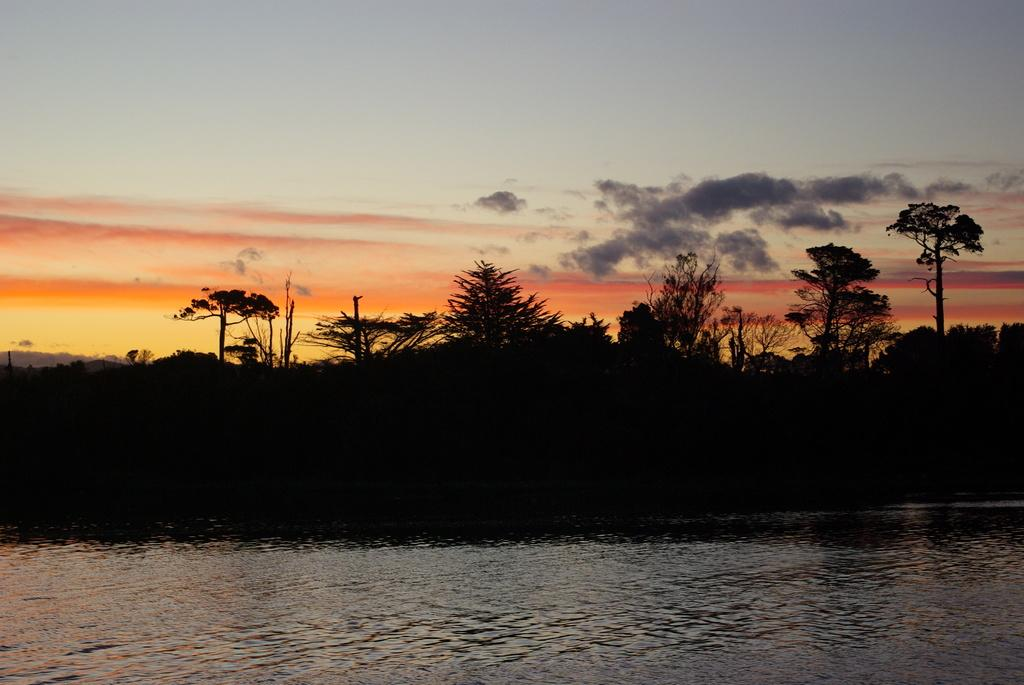What is the primary element visible in the image? There is water in the image. What can be seen in the background of the image? There are trees in the background of the image. What is visible in the sky in the image? There are clouds in the sky in the image. What type of knot can be seen tied around the tree in the image? There is no knot present in the image; it only features water, trees, and clouds. 